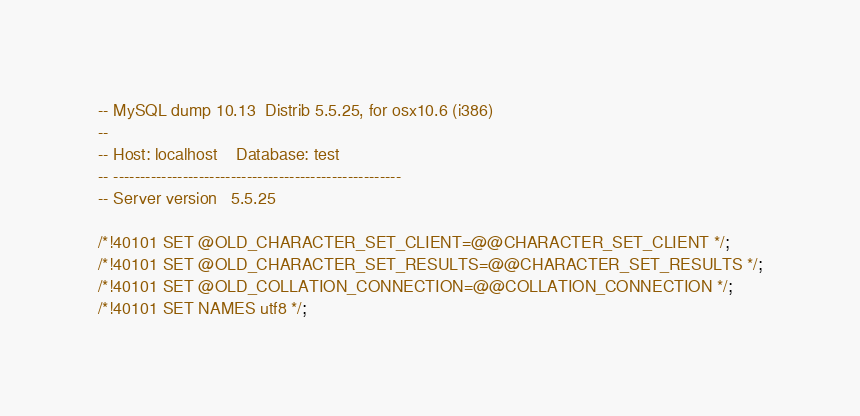<code> <loc_0><loc_0><loc_500><loc_500><_SQL_>-- MySQL dump 10.13  Distrib 5.5.25, for osx10.6 (i386)
--
-- Host: localhost    Database: test
-- ------------------------------------------------------
-- Server version	5.5.25

/*!40101 SET @OLD_CHARACTER_SET_CLIENT=@@CHARACTER_SET_CLIENT */;
/*!40101 SET @OLD_CHARACTER_SET_RESULTS=@@CHARACTER_SET_RESULTS */;
/*!40101 SET @OLD_COLLATION_CONNECTION=@@COLLATION_CONNECTION */;
/*!40101 SET NAMES utf8 */;</code> 